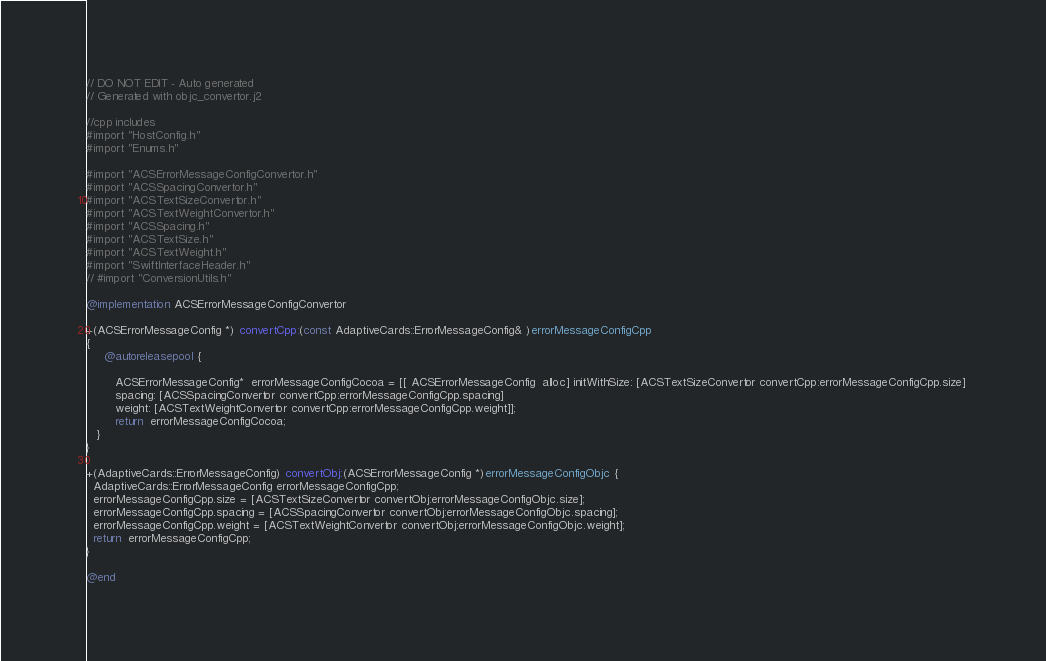Convert code to text. <code><loc_0><loc_0><loc_500><loc_500><_ObjectiveC_>// DO NOT EDIT - Auto generated
// Generated with objc_convertor.j2

//cpp includes 
#import "HostConfig.h"
#import "Enums.h"

#import "ACSErrorMessageConfigConvertor.h"
#import "ACSSpacingConvertor.h"
#import "ACSTextSizeConvertor.h"
#import "ACSTextWeightConvertor.h"
#import "ACSSpacing.h"
#import "ACSTextSize.h"
#import "ACSTextWeight.h"
#import "SwiftInterfaceHeader.h"
// #import "ConversionUtils.h"

@implementation ACSErrorMessageConfigConvertor 

+(ACSErrorMessageConfig *) convertCpp:(const AdaptiveCards::ErrorMessageConfig& )errorMessageConfigCpp
{ 
     @autoreleasepool { 
 
        ACSErrorMessageConfig*  errorMessageConfigCocoa = [[ ACSErrorMessageConfig  alloc] initWithSize: [ACSTextSizeConvertor convertCpp:errorMessageConfigCpp.size] 
        spacing: [ACSSpacingConvertor convertCpp:errorMessageConfigCpp.spacing]
        weight: [ACSTextWeightConvertor convertCpp:errorMessageConfigCpp.weight]];
        return  errorMessageConfigCocoa;
   }
}

+(AdaptiveCards::ErrorMessageConfig) convertObj:(ACSErrorMessageConfig *)errorMessageConfigObjc {
  AdaptiveCards::ErrorMessageConfig errorMessageConfigCpp;
  errorMessageConfigCpp.size = [ACSTextSizeConvertor convertObj:errorMessageConfigObjc.size];
  errorMessageConfigCpp.spacing = [ACSSpacingConvertor convertObj:errorMessageConfigObjc.spacing];
  errorMessageConfigCpp.weight = [ACSTextWeightConvertor convertObj:errorMessageConfigObjc.weight];
  return  errorMessageConfigCpp;
}

@end 
</code> 